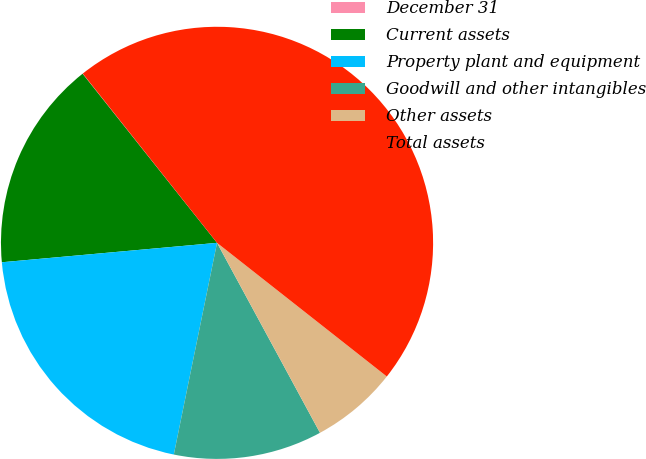Convert chart to OTSL. <chart><loc_0><loc_0><loc_500><loc_500><pie_chart><fcel>December 31<fcel>Current assets<fcel>Property plant and equipment<fcel>Goodwill and other intangibles<fcel>Other assets<fcel>Total assets<nl><fcel>0.02%<fcel>15.74%<fcel>20.36%<fcel>11.11%<fcel>6.48%<fcel>46.28%<nl></chart> 